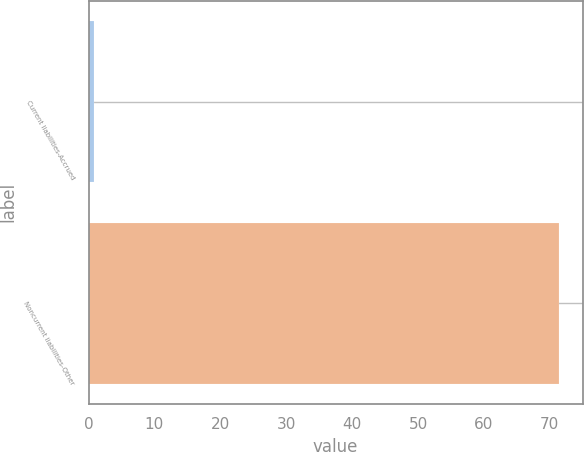Convert chart. <chart><loc_0><loc_0><loc_500><loc_500><bar_chart><fcel>Current liabilities-Accrued<fcel>Noncurrent liabilities-Other<nl><fcel>0.8<fcel>71.4<nl></chart> 